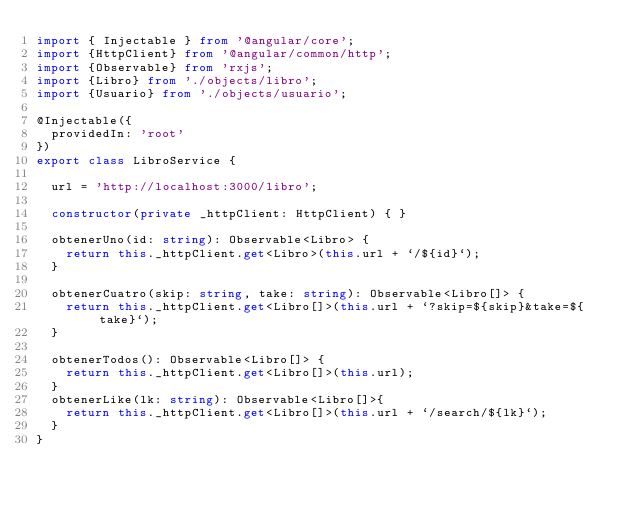Convert code to text. <code><loc_0><loc_0><loc_500><loc_500><_TypeScript_>import { Injectable } from '@angular/core';
import {HttpClient} from '@angular/common/http';
import {Observable} from 'rxjs';
import {Libro} from './objects/libro';
import {Usuario} from './objects/usuario';

@Injectable({
  providedIn: 'root'
})
export class LibroService {

  url = 'http://localhost:3000/libro';

  constructor(private _httpClient: HttpClient) { }

  obtenerUno(id: string): Observable<Libro> {
    return this._httpClient.get<Libro>(this.url + `/${id}`);
  }

  obtenerCuatro(skip: string, take: string): Observable<Libro[]> {
    return this._httpClient.get<Libro[]>(this.url + `?skip=${skip}&take=${take}`);
  }

  obtenerTodos(): Observable<Libro[]> {
    return this._httpClient.get<Libro[]>(this.url);
  }
  obtenerLike(lk: string): Observable<Libro[]>{
    return this._httpClient.get<Libro[]>(this.url + `/search/${lk}`);
  }
}
</code> 